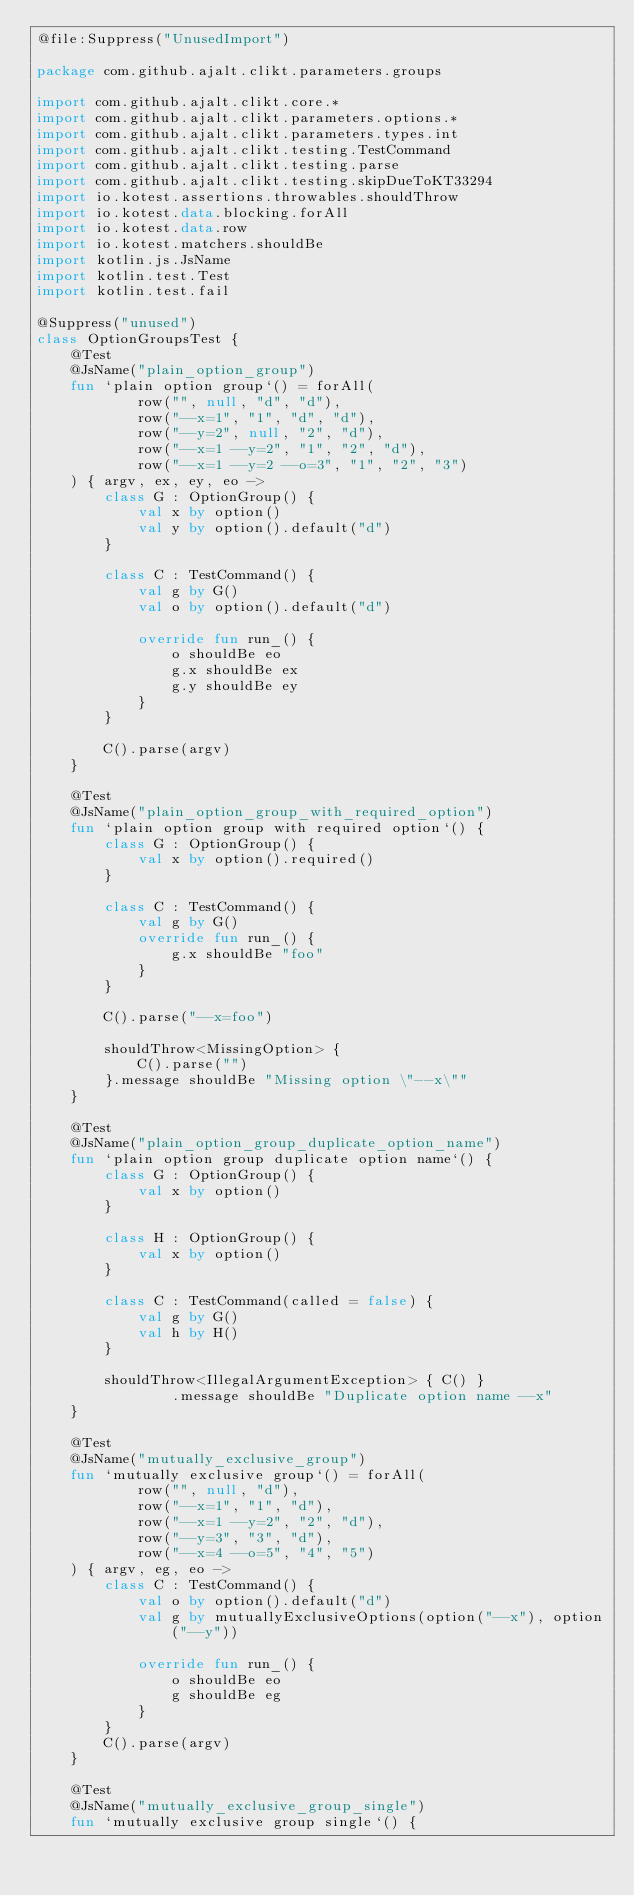Convert code to text. <code><loc_0><loc_0><loc_500><loc_500><_Kotlin_>@file:Suppress("UnusedImport")

package com.github.ajalt.clikt.parameters.groups

import com.github.ajalt.clikt.core.*
import com.github.ajalt.clikt.parameters.options.*
import com.github.ajalt.clikt.parameters.types.int
import com.github.ajalt.clikt.testing.TestCommand
import com.github.ajalt.clikt.testing.parse
import com.github.ajalt.clikt.testing.skipDueToKT33294
import io.kotest.assertions.throwables.shouldThrow
import io.kotest.data.blocking.forAll
import io.kotest.data.row
import io.kotest.matchers.shouldBe
import kotlin.js.JsName
import kotlin.test.Test
import kotlin.test.fail

@Suppress("unused")
class OptionGroupsTest {
    @Test
    @JsName("plain_option_group")
    fun `plain option group`() = forAll(
            row("", null, "d", "d"),
            row("--x=1", "1", "d", "d"),
            row("--y=2", null, "2", "d"),
            row("--x=1 --y=2", "1", "2", "d"),
            row("--x=1 --y=2 --o=3", "1", "2", "3")
    ) { argv, ex, ey, eo ->
        class G : OptionGroup() {
            val x by option()
            val y by option().default("d")
        }

        class C : TestCommand() {
            val g by G()
            val o by option().default("d")

            override fun run_() {
                o shouldBe eo
                g.x shouldBe ex
                g.y shouldBe ey
            }
        }

        C().parse(argv)
    }

    @Test
    @JsName("plain_option_group_with_required_option")
    fun `plain option group with required option`() {
        class G : OptionGroup() {
            val x by option().required()
        }

        class C : TestCommand() {
            val g by G()
            override fun run_() {
                g.x shouldBe "foo"
            }
        }

        C().parse("--x=foo")

        shouldThrow<MissingOption> {
            C().parse("")
        }.message shouldBe "Missing option \"--x\""
    }

    @Test
    @JsName("plain_option_group_duplicate_option_name")
    fun `plain option group duplicate option name`() {
        class G : OptionGroup() {
            val x by option()
        }

        class H : OptionGroup() {
            val x by option()
        }

        class C : TestCommand(called = false) {
            val g by G()
            val h by H()
        }

        shouldThrow<IllegalArgumentException> { C() }
                .message shouldBe "Duplicate option name --x"
    }

    @Test
    @JsName("mutually_exclusive_group")
    fun `mutually exclusive group`() = forAll(
            row("", null, "d"),
            row("--x=1", "1", "d"),
            row("--x=1 --y=2", "2", "d"),
            row("--y=3", "3", "d"),
            row("--x=4 --o=5", "4", "5")
    ) { argv, eg, eo ->
        class C : TestCommand() {
            val o by option().default("d")
            val g by mutuallyExclusiveOptions(option("--x"), option("--y"))

            override fun run_() {
                o shouldBe eo
                g shouldBe eg
            }
        }
        C().parse(argv)
    }

    @Test
    @JsName("mutually_exclusive_group_single")
    fun `mutually exclusive group single`() {</code> 